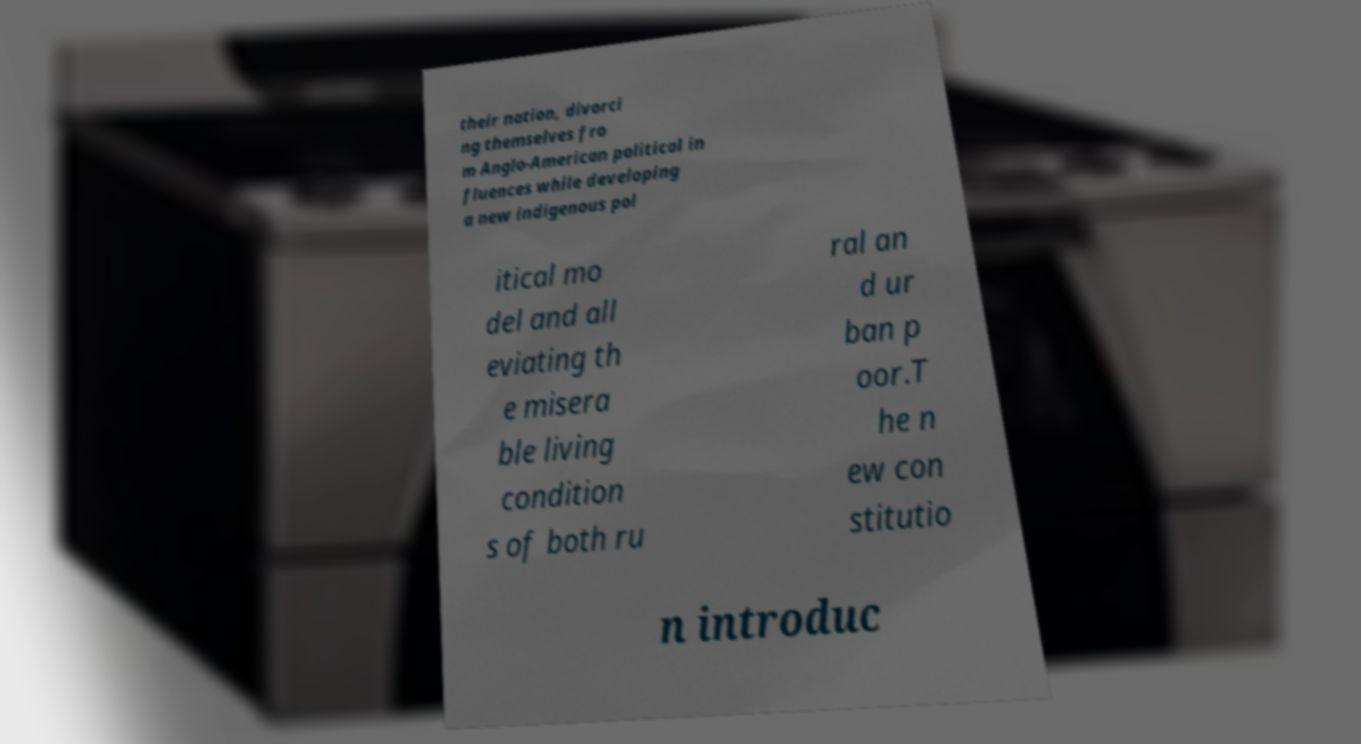Could you extract and type out the text from this image? their nation, divorci ng themselves fro m Anglo-American political in fluences while developing a new indigenous pol itical mo del and all eviating th e misera ble living condition s of both ru ral an d ur ban p oor.T he n ew con stitutio n introduc 